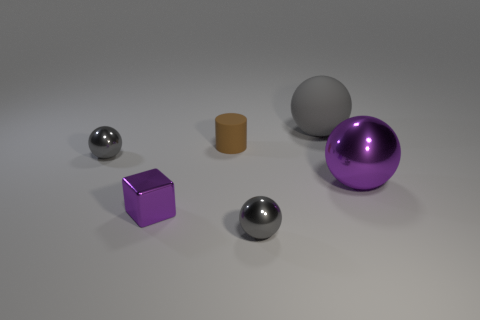Subtract all yellow cylinders. How many gray balls are left? 3 Subtract 1 balls. How many balls are left? 3 Subtract all brown balls. Subtract all gray cylinders. How many balls are left? 4 Add 1 large matte spheres. How many objects exist? 7 Subtract all cylinders. How many objects are left? 5 Subtract all tiny balls. Subtract all gray matte objects. How many objects are left? 3 Add 1 cubes. How many cubes are left? 2 Add 5 large gray shiny things. How many large gray shiny things exist? 5 Subtract 0 red blocks. How many objects are left? 6 